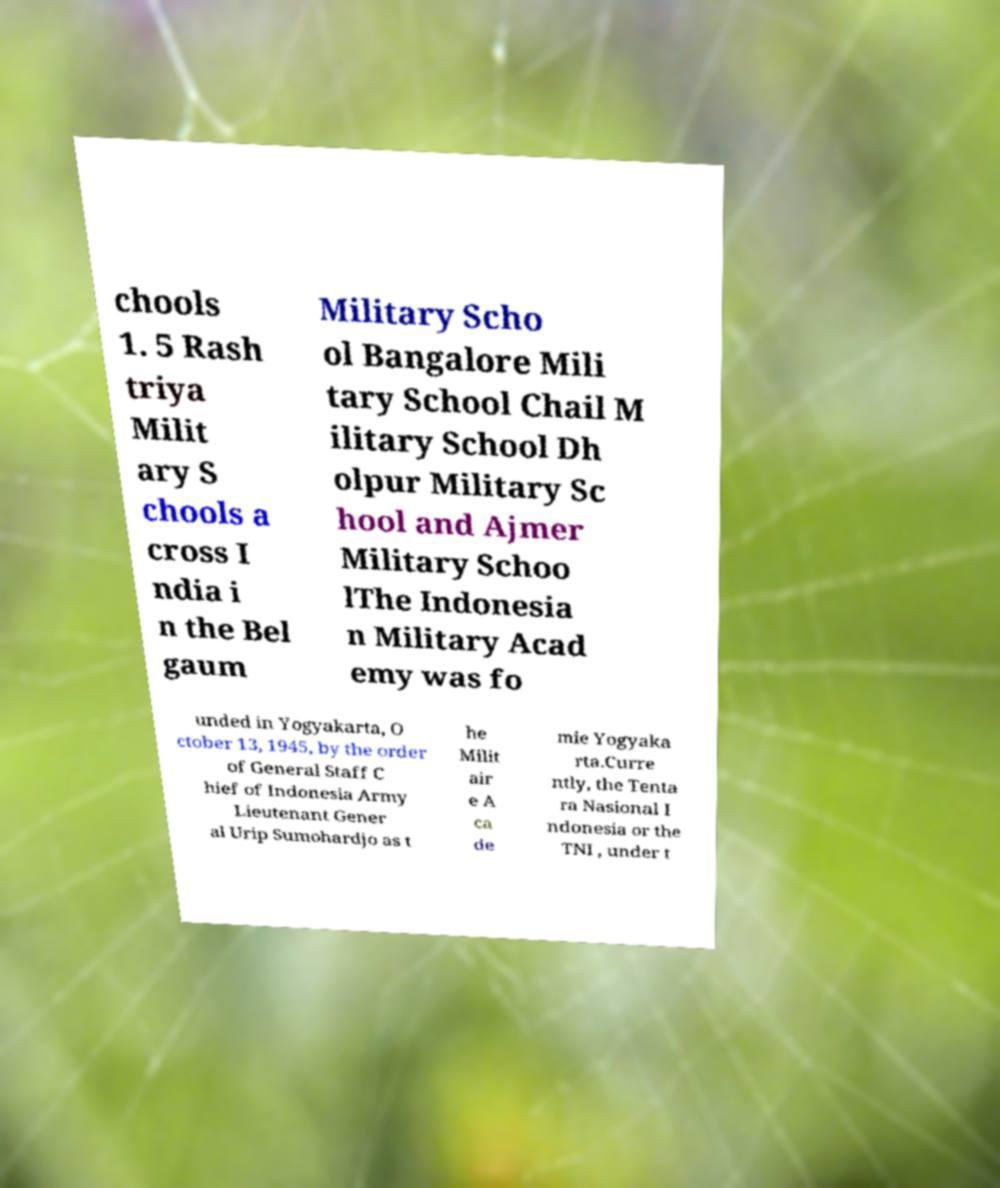Can you accurately transcribe the text from the provided image for me? chools 1. 5 Rash triya Milit ary S chools a cross I ndia i n the Bel gaum Military Scho ol Bangalore Mili tary School Chail M ilitary School Dh olpur Military Sc hool and Ajmer Military Schoo lThe Indonesia n Military Acad emy was fo unded in Yogyakarta, O ctober 13, 1945, by the order of General Staff C hief of Indonesia Army Lieutenant Gener al Urip Sumohardjo as t he Milit air e A ca de mie Yogyaka rta.Curre ntly, the Tenta ra Nasional I ndonesia or the TNI , under t 